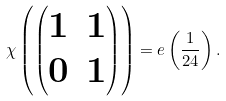<formula> <loc_0><loc_0><loc_500><loc_500>\chi \left ( \begin{pmatrix} 1 & 1 \\ 0 & 1 \end{pmatrix} \right ) = e \left ( \frac { 1 } { 2 4 } \right ) .</formula> 